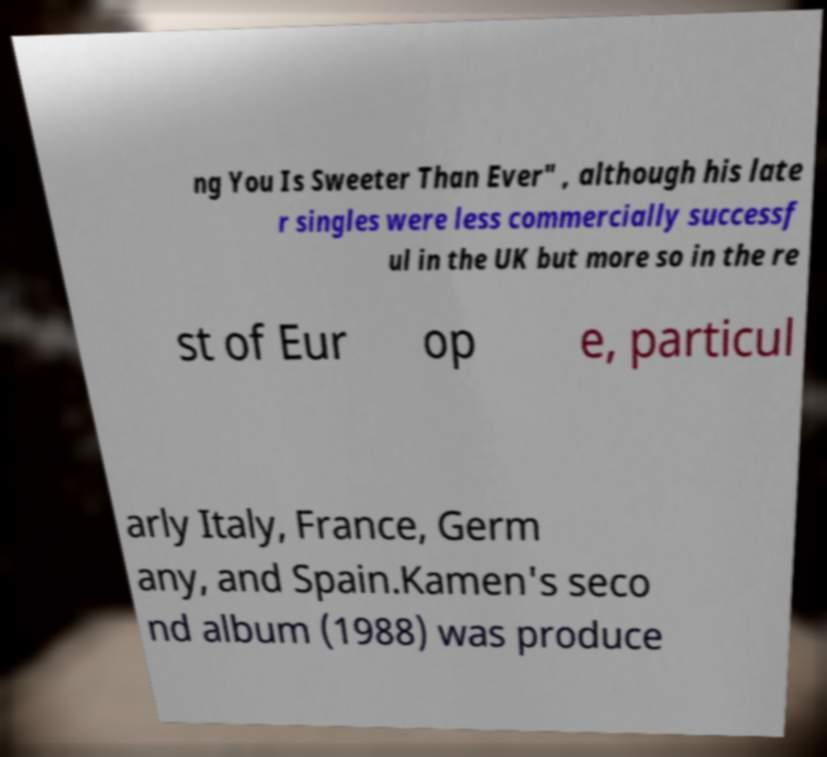Can you accurately transcribe the text from the provided image for me? ng You Is Sweeter Than Ever" , although his late r singles were less commercially successf ul in the UK but more so in the re st of Eur op e, particul arly Italy, France, Germ any, and Spain.Kamen's seco nd album (1988) was produce 